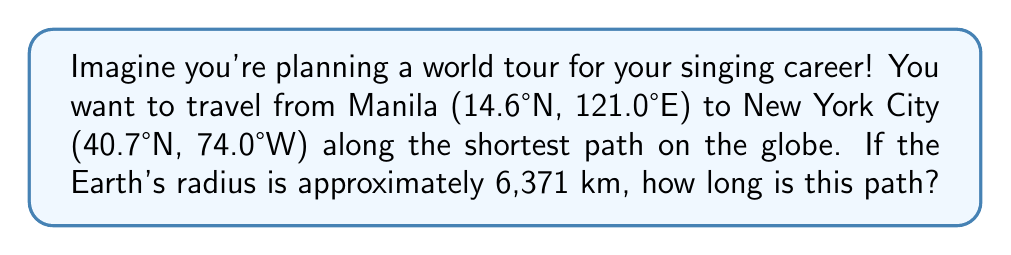Can you answer this question? Let's solve this step-by-step:

1) The shortest path between two points on a sphere is along a great circle, which is called the geodesic.

2) To find the length of this path, we need to calculate the central angle between the two points and then use it to find the arc length.

3) We can use the haversine formula to calculate the central angle:

   $$\text{hav}(\theta) = \text{hav}(\phi_2 - \phi_1) + \cos(\phi_1)\cos(\phi_2)\text{hav}(\lambda_2 - \lambda_1)$$

   Where $\phi$ is latitude and $\lambda$ is longitude.

4) First, let's convert our coordinates to radians:
   Manila: $\phi_1 = 14.6° \times \frac{\pi}{180} = 0.2548$ rad, $\lambda_1 = 121.0° \times \frac{\pi}{180} = 2.1117$ rad
   New York: $\phi_2 = 40.7° \times \frac{\pi}{180} = 0.7101$ rad, $\lambda_2 = -74.0° \times \frac{\pi}{180} = -1.2915$ rad

5) Now we can calculate:
   $$\text{hav}(\theta) = \text{hav}(0.7101 - 0.2548) + \cos(0.2548)\cos(0.7101)\text{hav}(-1.2915 - 2.1117)$$

6) Simplify:
   $$\text{hav}(\theta) = \text{hav}(0.4553) + \cos(0.2548)\cos(0.7101)\text{hav}(-3.4032)$$

7) Calculate:
   $$\text{hav}(\theta) = 0.0506 + 0.9678 \times 0.7602 \times 0.7639 = 0.5012$$

8) The inverse haversine gives us $\theta$:
   $$\theta = 2 \times \arcsin(\sqrt{0.5012}) = 2.4845 \text{ radians}$$

9) Now we can calculate the arc length:
   $$s = R\theta = 6371 \times 2.4845 = 15,828 \text{ km}$$

Therefore, the shortest path between Manila and New York City is approximately 15,828 km.
Answer: 15,828 km 